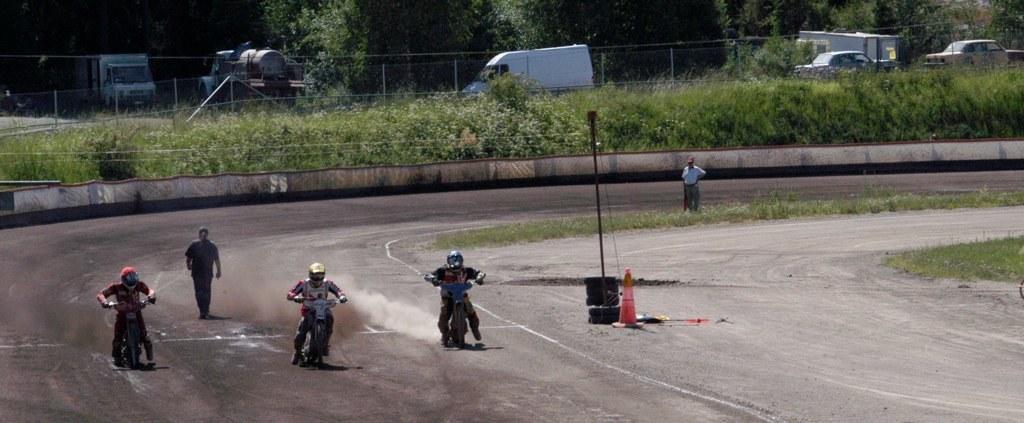In one or two sentences, can you explain what this image depicts? In this picture we can see three persons riding motor bikes and a person walking on the road, traffic cone, grass, fence, trees, vehicles and in the background we can see a man standing. 